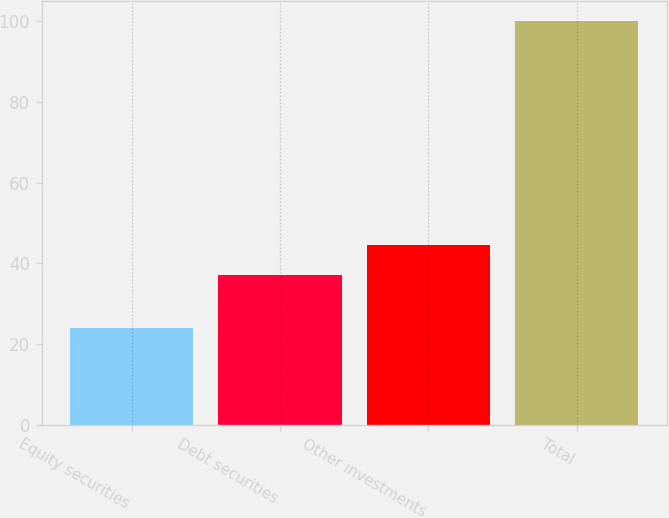<chart> <loc_0><loc_0><loc_500><loc_500><bar_chart><fcel>Equity securities<fcel>Debt securities<fcel>Other investments<fcel>Total<nl><fcel>24<fcel>37<fcel>44.6<fcel>100<nl></chart> 